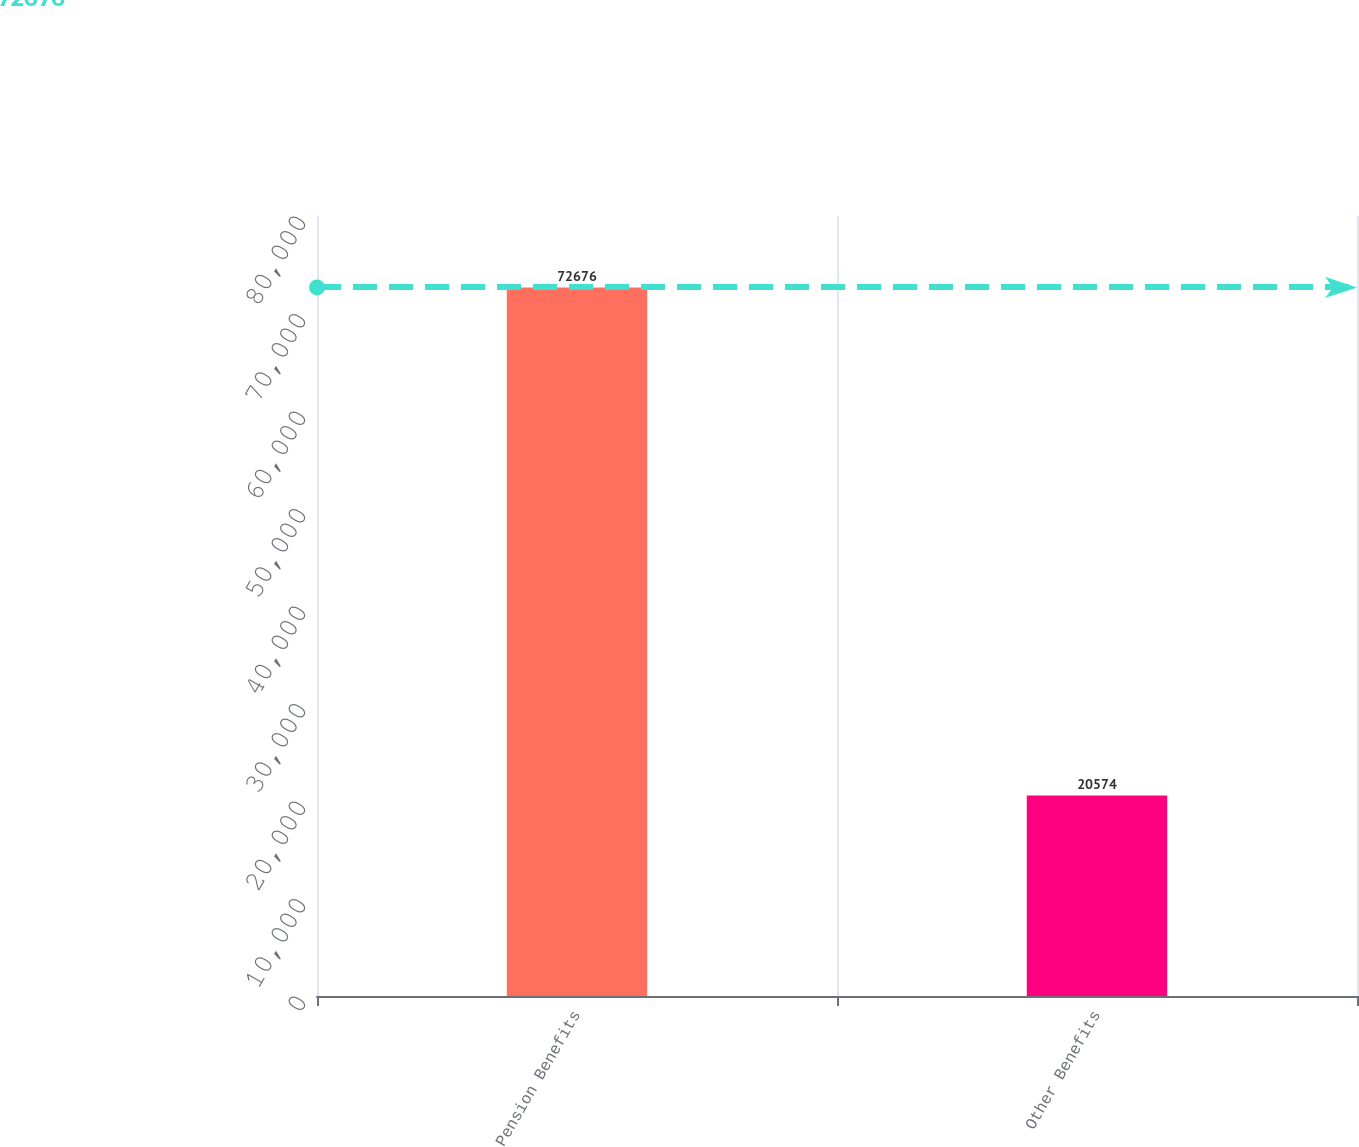Convert chart. <chart><loc_0><loc_0><loc_500><loc_500><bar_chart><fcel>Pension Benefits<fcel>Other Benefits<nl><fcel>72676<fcel>20574<nl></chart> 